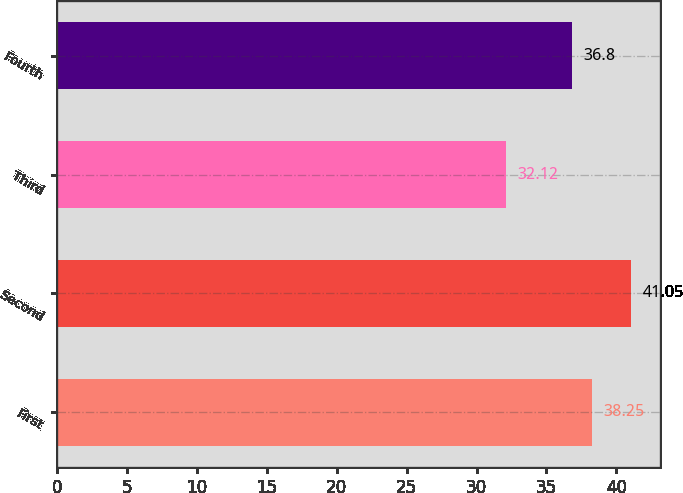Convert chart. <chart><loc_0><loc_0><loc_500><loc_500><bar_chart><fcel>First<fcel>Second<fcel>Third<fcel>Fourth<nl><fcel>38.25<fcel>41.05<fcel>32.12<fcel>36.8<nl></chart> 